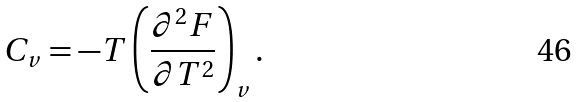Convert formula to latex. <formula><loc_0><loc_0><loc_500><loc_500>C _ { v } = - T \left ( \frac { \partial ^ { 2 } F } { \partial T ^ { 2 } } \right ) _ { v } .</formula> 